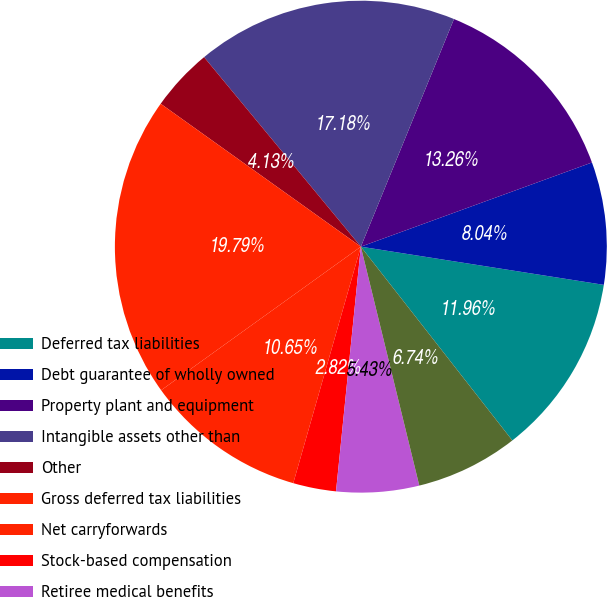<chart> <loc_0><loc_0><loc_500><loc_500><pie_chart><fcel>Deferred tax liabilities<fcel>Debt guarantee of wholly owned<fcel>Property plant and equipment<fcel>Intangible assets other than<fcel>Other<fcel>Gross deferred tax liabilities<fcel>Net carryforwards<fcel>Stock-based compensation<fcel>Retiree medical benefits<fcel>Other employee-related<nl><fcel>11.96%<fcel>8.04%<fcel>13.26%<fcel>17.18%<fcel>4.13%<fcel>19.79%<fcel>10.65%<fcel>2.82%<fcel>5.43%<fcel>6.74%<nl></chart> 